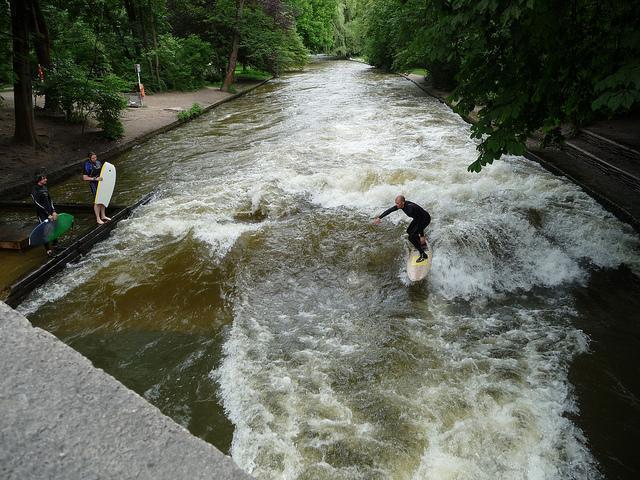Tidal bores surfing can be played on which water?
Make your selection and explain in format: 'Answer: answer
Rationale: rationale.'
Options: Ocean, pond, river, sea. Answer: river.
Rationale: The man is surfing in a river since the body of water is narrow. 